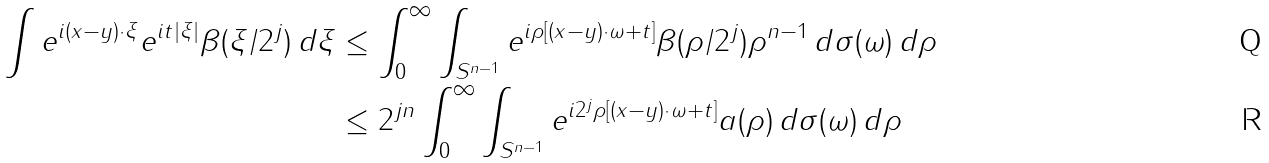Convert formula to latex. <formula><loc_0><loc_0><loc_500><loc_500>\int e ^ { i ( x - y ) \cdot \xi } e ^ { i t | \xi | } \beta ( \xi / 2 ^ { j } ) \, d \xi & \leq \int _ { 0 } ^ { \infty } \int _ { S ^ { n - 1 } } e ^ { i \rho [ ( x - y ) \cdot \omega + t ] } \beta ( \rho / 2 ^ { j } ) \rho ^ { n - 1 } \, d \sigma ( \omega ) \, d \rho \\ & \leq 2 ^ { j n } \int _ { 0 } ^ { \infty } \int _ { S ^ { n - 1 } } e ^ { i 2 ^ { j } \rho [ ( x - y ) \cdot \omega + t ] } a ( \rho ) \, d \sigma ( \omega ) \, d \rho</formula> 